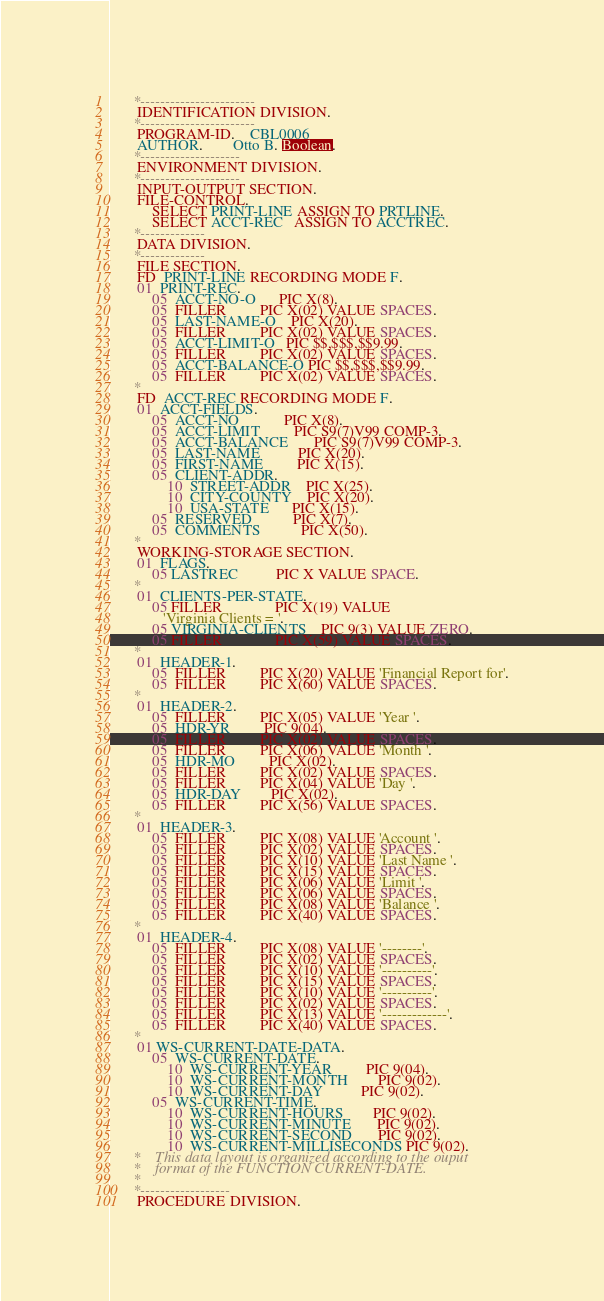Convert code to text. <code><loc_0><loc_0><loc_500><loc_500><_COBOL_>      *-----------------------
       IDENTIFICATION DIVISION.
      *-----------------------
       PROGRAM-ID.    CBL0006
       AUTHOR.        Otto B. Boolean.
      *--------------------
       ENVIRONMENT DIVISION.
      *--------------------
       INPUT-OUTPUT SECTION.
       FILE-CONTROL.
           SELECT PRINT-LINE ASSIGN TO PRTLINE.
           SELECT ACCT-REC   ASSIGN TO ACCTREC.
      *-------------
       DATA DIVISION.
      *-------------
       FILE SECTION.
       FD  PRINT-LINE RECORDING MODE F.
       01  PRINT-REC.
           05  ACCT-NO-O      PIC X(8).
           05  FILLER         PIC X(02) VALUE SPACES.
           05  LAST-NAME-O    PIC X(20).
           05  FILLER         PIC X(02) VALUE SPACES.
           05  ACCT-LIMIT-O   PIC $$,$$$,$$9.99.
           05  FILLER         PIC X(02) VALUE SPACES.
           05  ACCT-BALANCE-O PIC $$,$$$,$$9.99.
           05  FILLER         PIC X(02) VALUE SPACES.
      *
       FD  ACCT-REC RECORDING MODE F.
       01  ACCT-FIELDS.
           05  ACCT-NO            PIC X(8).
           05  ACCT-LIMIT         PIC S9(7)V99 COMP-3.
           05  ACCT-BALANCE       PIC S9(7)V99 COMP-3.
           05  LAST-NAME          PIC X(20).
           05  FIRST-NAME         PIC X(15).
           05  CLIENT-ADDR.
               10  STREET-ADDR    PIC X(25).
               10  CITY-COUNTY    PIC X(20).
               10  USA-STATE      PIC X(15).
           05  RESERVED           PIC X(7).
           05  COMMENTS           PIC X(50).
      *
       WORKING-STORAGE SECTION.
       01  FLAGS.
           05 LASTREC          PIC X VALUE SPACE.
      *
       01  CLIENTS-PER-STATE.
           05 FILLER              PIC X(19) VALUE
              'Virginia Clients = '.
           05 VIRGINIA-CLIENTS    PIC 9(3) VALUE ZERO.
           05 FILLER              PIC X(59) VALUE SPACES.
      *
       01  HEADER-1.
           05  FILLER         PIC X(20) VALUE 'Financial Report for'.
           05  FILLER         PIC X(60) VALUE SPACES.
      *
       01  HEADER-2.
           05  FILLER         PIC X(05) VALUE 'Year '.
           05  HDR-YR         PIC 9(04).
           05  FILLER         PIC X(02) VALUE SPACES.
           05  FILLER         PIC X(06) VALUE 'Month '.
           05  HDR-MO         PIC X(02).
           05  FILLER         PIC X(02) VALUE SPACES.
           05  FILLER         PIC X(04) VALUE 'Day '.
           05  HDR-DAY        PIC X(02).
           05  FILLER         PIC X(56) VALUE SPACES.
      *
       01  HEADER-3.
           05  FILLER         PIC X(08) VALUE 'Account '.
           05  FILLER         PIC X(02) VALUE SPACES.
           05  FILLER         PIC X(10) VALUE 'Last Name '.
           05  FILLER         PIC X(15) VALUE SPACES.
           05  FILLER         PIC X(06) VALUE 'Limit '.
           05  FILLER         PIC X(06) VALUE SPACES.
           05  FILLER         PIC X(08) VALUE 'Balance '.
           05  FILLER         PIC X(40) VALUE SPACES.
      *
       01  HEADER-4.
           05  FILLER         PIC X(08) VALUE '--------'.
           05  FILLER         PIC X(02) VALUE SPACES.
           05  FILLER         PIC X(10) VALUE '----------'.
           05  FILLER         PIC X(15) VALUE SPACES.
           05  FILLER         PIC X(10) VALUE '----------'.
           05  FILLER         PIC X(02) VALUE SPACES.
           05  FILLER         PIC X(13) VALUE '-------------'.
           05  FILLER         PIC X(40) VALUE SPACES.
      *
       01 WS-CURRENT-DATE-DATA.
           05  WS-CURRENT-DATE.
               10  WS-CURRENT-YEAR         PIC 9(04).
               10  WS-CURRENT-MONTH        PIC 9(02).
               10  WS-CURRENT-DAY          PIC 9(02).
           05  WS-CURRENT-TIME.
               10  WS-CURRENT-HOURS        PIC 9(02).
               10  WS-CURRENT-MINUTE       PIC 9(02).
               10  WS-CURRENT-SECOND       PIC 9(02).
               10  WS-CURRENT-MILLISECONDS PIC 9(02).
      *    This data layout is organized according to the ouput
      *    format of the FUNCTION CURRENT-DATE.
      *
      *------------------
       PROCEDURE DIVISION.</code> 